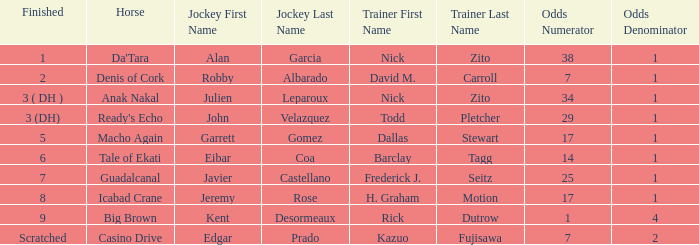What are the Odds for Trainer Barclay Tagg? 14-1. 